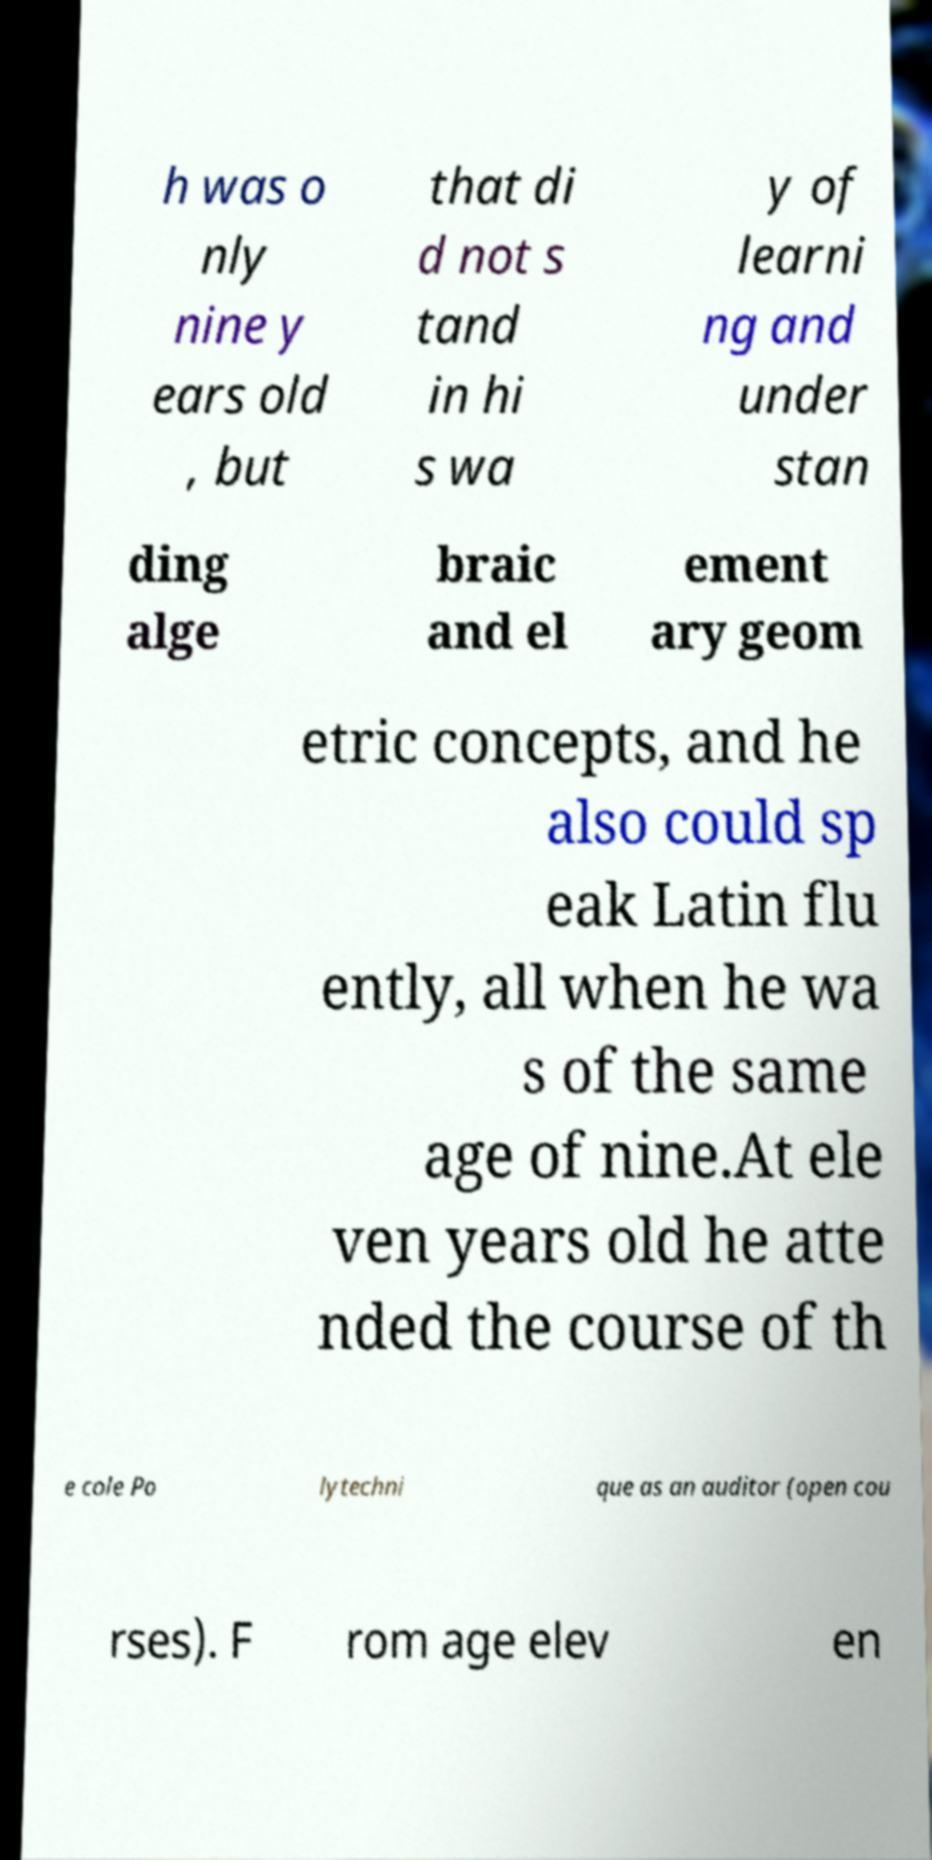There's text embedded in this image that I need extracted. Can you transcribe it verbatim? h was o nly nine y ears old , but that di d not s tand in hi s wa y of learni ng and under stan ding alge braic and el ement ary geom etric concepts, and he also could sp eak Latin flu ently, all when he wa s of the same age of nine.At ele ven years old he atte nded the course of th e cole Po lytechni que as an auditor (open cou rses). F rom age elev en 